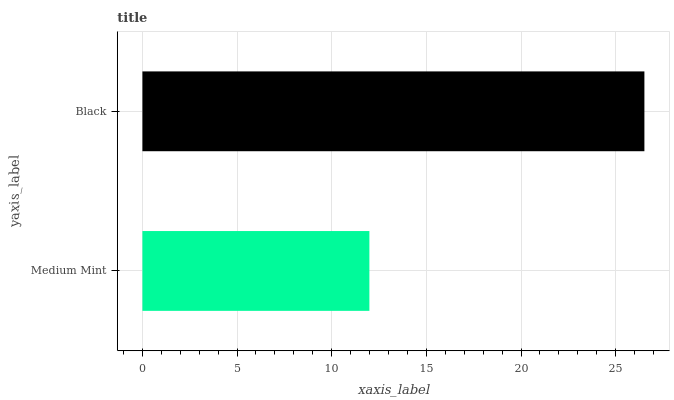Is Medium Mint the minimum?
Answer yes or no. Yes. Is Black the maximum?
Answer yes or no. Yes. Is Black the minimum?
Answer yes or no. No. Is Black greater than Medium Mint?
Answer yes or no. Yes. Is Medium Mint less than Black?
Answer yes or no. Yes. Is Medium Mint greater than Black?
Answer yes or no. No. Is Black less than Medium Mint?
Answer yes or no. No. Is Black the high median?
Answer yes or no. Yes. Is Medium Mint the low median?
Answer yes or no. Yes. Is Medium Mint the high median?
Answer yes or no. No. Is Black the low median?
Answer yes or no. No. 